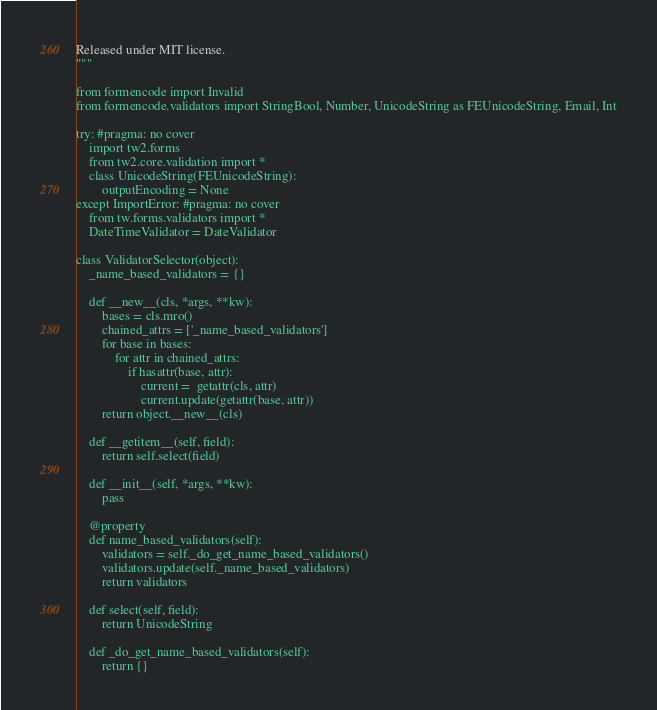<code> <loc_0><loc_0><loc_500><loc_500><_Python_>Released under MIT license.
"""

from formencode import Invalid
from formencode.validators import StringBool, Number, UnicodeString as FEUnicodeString, Email, Int

try: #pragma: no cover
    import tw2.forms
    from tw2.core.validation import *
    class UnicodeString(FEUnicodeString):
        outputEncoding = None
except ImportError: #pragma: no cover
    from tw.forms.validators import *
    DateTimeValidator = DateValidator

class ValidatorSelector(object):
    _name_based_validators = {}

    def __new__(cls, *args, **kw):
        bases = cls.mro()
        chained_attrs = ['_name_based_validators']
        for base in bases:
            for attr in chained_attrs:
                if hasattr(base, attr):
                    current =  getattr(cls, attr)
                    current.update(getattr(base, attr))
        return object.__new__(cls)

    def __getitem__(self, field):
        return self.select(field)

    def __init__(self, *args, **kw):
        pass

    @property
    def name_based_validators(self):
        validators = self._do_get_name_based_validators()
        validators.update(self._name_based_validators)
        return validators

    def select(self, field):
        return UnicodeString

    def _do_get_name_based_validators(self):
        return {}
</code> 